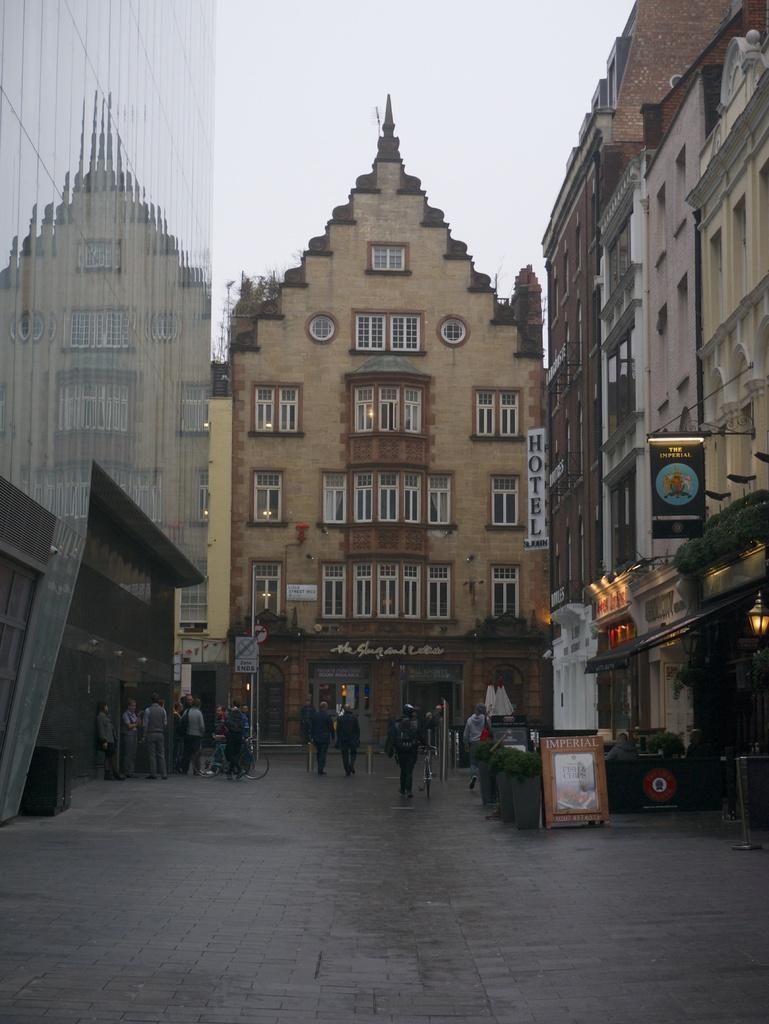Can you describe this image briefly? At the bottom few people are walking on the street, there are buildings. At the top it is the sky. 